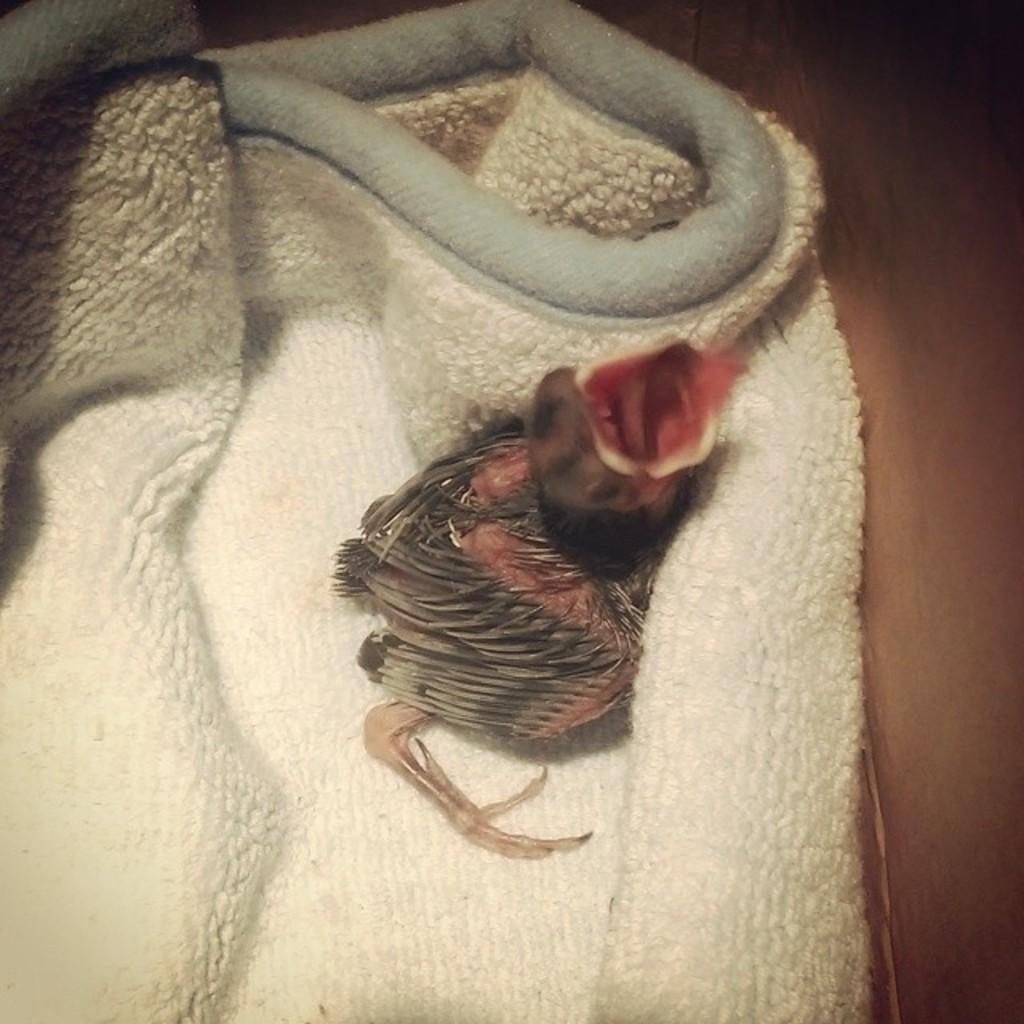What type of animal is in the image? There is a small bird in the image. Where is the bird located? The bird is inside a towel. What type of hole can be seen in the image? There is no hole present in the image. What kind of clam is visible in the image? There is no clam present in the image. 